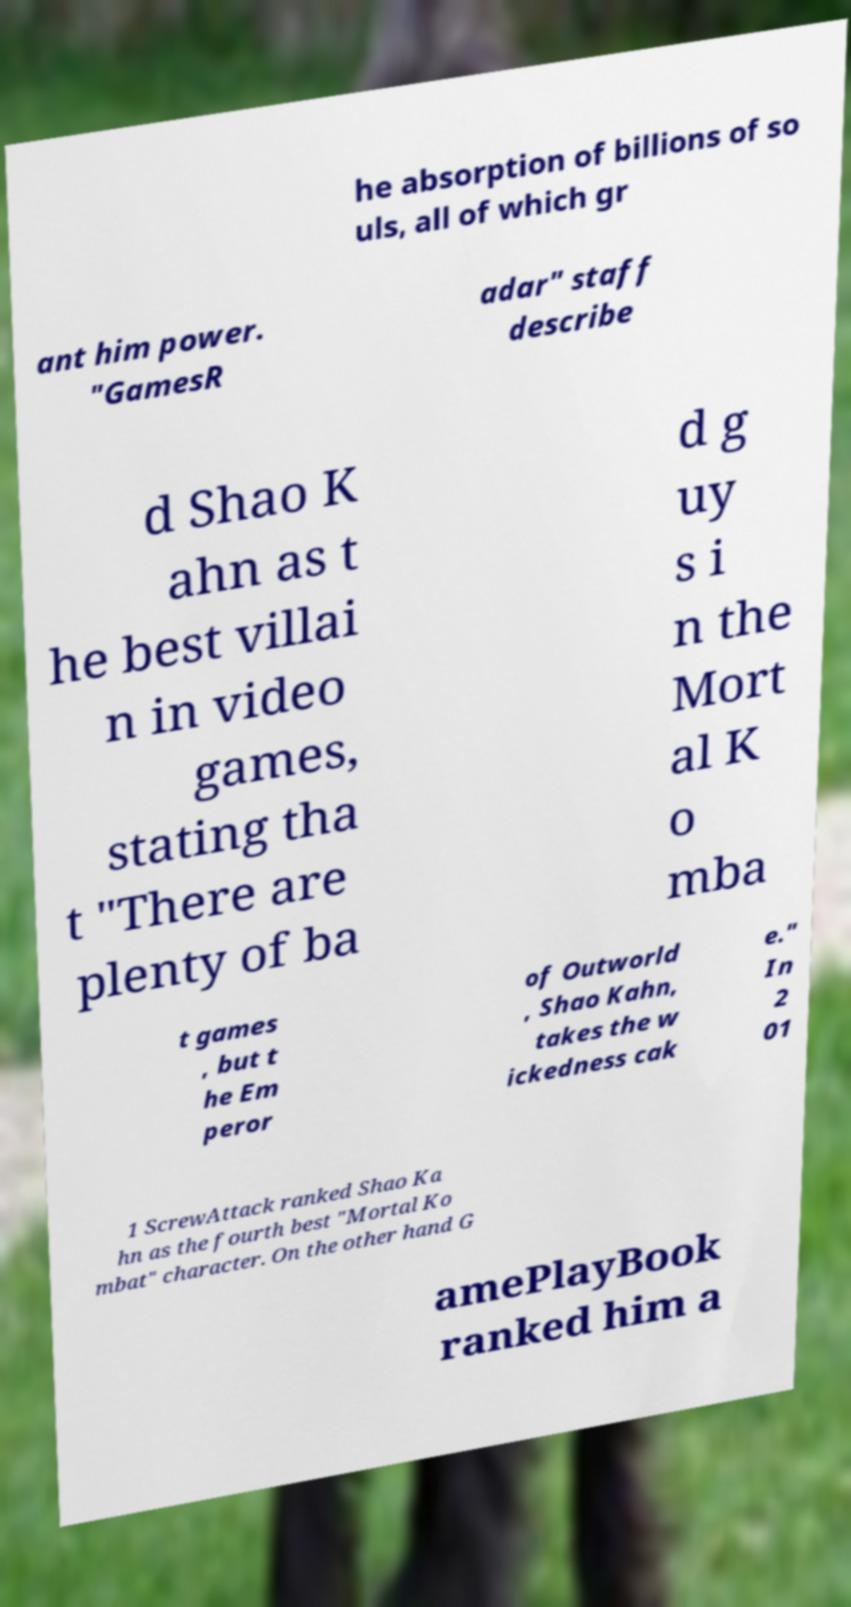Please read and relay the text visible in this image. What does it say? he absorption of billions of so uls, all of which gr ant him power. "GamesR adar" staff describe d Shao K ahn as t he best villai n in video games, stating tha t "There are plenty of ba d g uy s i n the Mort al K o mba t games , but t he Em peror of Outworld , Shao Kahn, takes the w ickedness cak e." In 2 01 1 ScrewAttack ranked Shao Ka hn as the fourth best "Mortal Ko mbat" character. On the other hand G amePlayBook ranked him a 